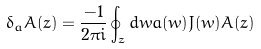<formula> <loc_0><loc_0><loc_500><loc_500>\delta _ { a } A ( z ) = \frac { - 1 } { 2 \pi i } \oint _ { z } d w a ( w ) J ( w ) A ( z )</formula> 